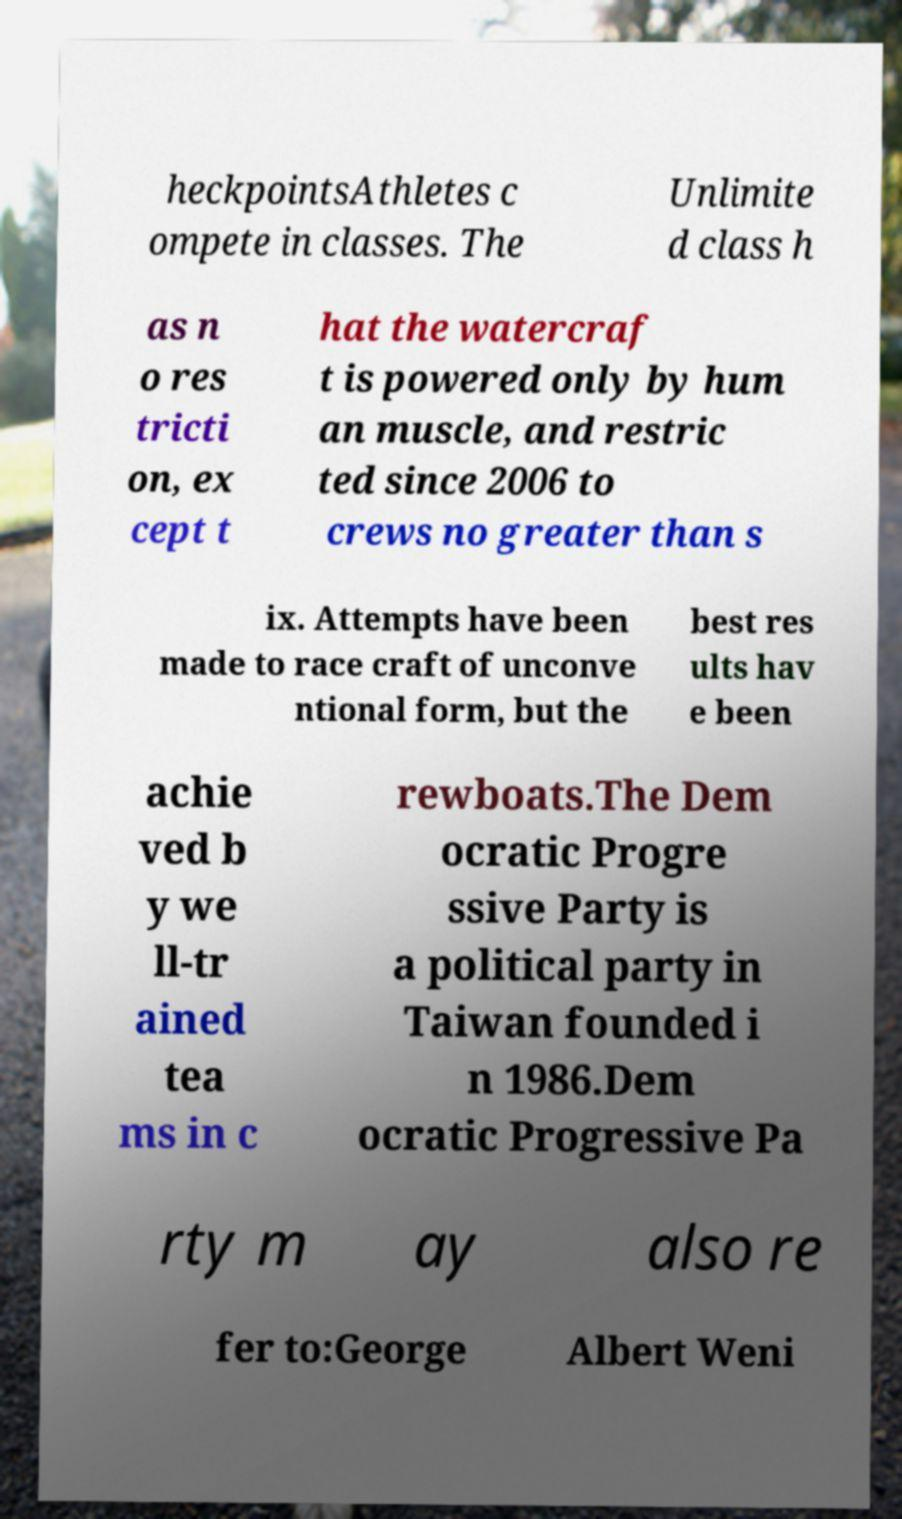I need the written content from this picture converted into text. Can you do that? heckpointsAthletes c ompete in classes. The Unlimite d class h as n o res tricti on, ex cept t hat the watercraf t is powered only by hum an muscle, and restric ted since 2006 to crews no greater than s ix. Attempts have been made to race craft of unconve ntional form, but the best res ults hav e been achie ved b y we ll-tr ained tea ms in c rewboats.The Dem ocratic Progre ssive Party is a political party in Taiwan founded i n 1986.Dem ocratic Progressive Pa rty m ay also re fer to:George Albert Weni 